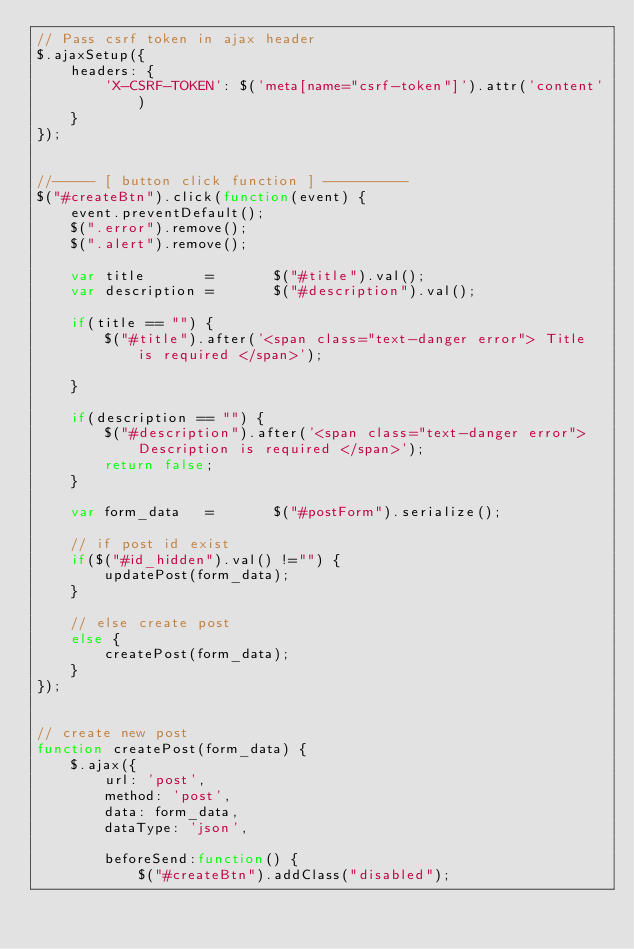Convert code to text. <code><loc_0><loc_0><loc_500><loc_500><_JavaScript_>// Pass csrf token in ajax header
$.ajaxSetup({
    headers: {
        'X-CSRF-TOKEN': $('meta[name="csrf-token"]').attr('content')
    }
});


//----- [ button click function ] ----------
$("#createBtn").click(function(event) {
    event.preventDefault();
    $(".error").remove();
    $(".alert").remove();

    var title       =       $("#title").val();
    var description =       $("#description").val();

    if(title == "") {
        $("#title").after('<span class="text-danger error"> Title is required </span>');

    }

    if(description == "") {
        $("#description").after('<span class="text-danger error"> Description is required </span>');
        return false;
    }

    var form_data   =       $("#postForm").serialize();

    // if post id exist
    if($("#id_hidden").val() !="") {
        updatePost(form_data);
    }

    // else create post
    else {
        createPost(form_data);
    }
});


// create new post
function createPost(form_data) {
    $.ajax({
        url: 'post',
        method: 'post',
        data: form_data,
        dataType: 'json',

        beforeSend:function() {
            $("#createBtn").addClass("disabled");</code> 